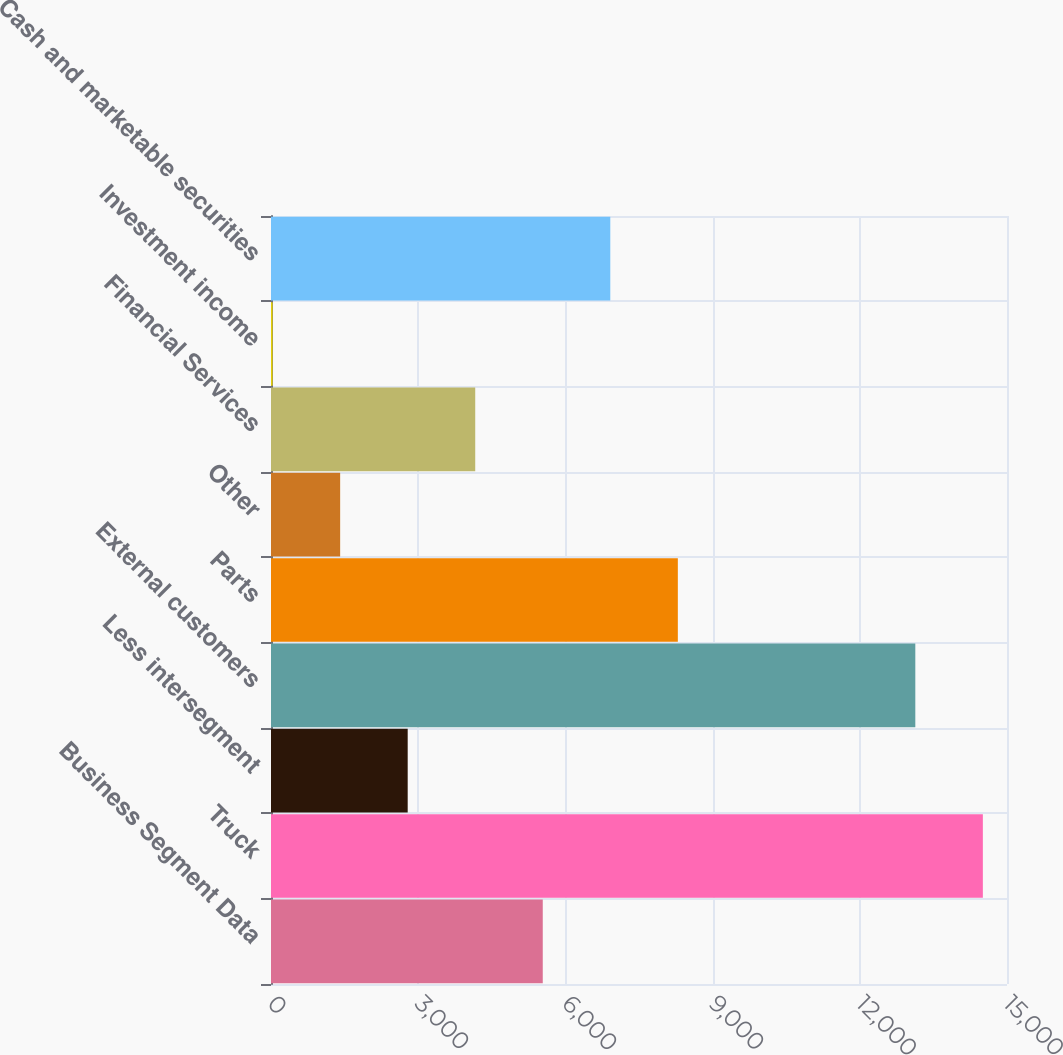Convert chart. <chart><loc_0><loc_0><loc_500><loc_500><bar_chart><fcel>Business Segment Data<fcel>Truck<fcel>Less intersegment<fcel>External customers<fcel>Parts<fcel>Other<fcel>Financial Services<fcel>Investment income<fcel>Cash and marketable securities<nl><fcel>5538.7<fcel>14507.9<fcel>2785.9<fcel>13131.5<fcel>8291.5<fcel>1409.5<fcel>4162.3<fcel>33.1<fcel>6915.1<nl></chart> 